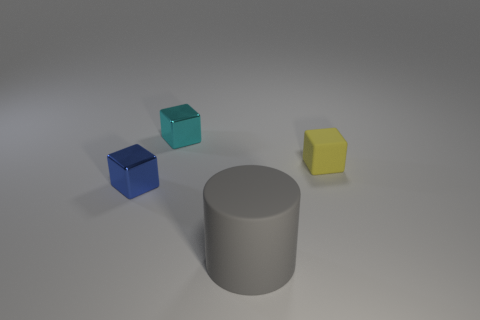Are there more big purple matte cylinders than gray objects?
Make the answer very short. No. Do the tiny blue object and the large gray cylinder that is left of the yellow cube have the same material?
Give a very brief answer. No. How many objects are either matte cubes or tiny metallic things?
Ensure brevity in your answer.  3. Is the size of the matte thing behind the tiny blue thing the same as the rubber thing in front of the tiny yellow thing?
Provide a succinct answer. No. How many cylinders are matte objects or tiny yellow matte things?
Give a very brief answer. 1. Are there any small red things?
Offer a terse response. No. Is there any other thing that has the same shape as the large rubber thing?
Offer a very short reply. No. What number of things are either shiny cubes on the right side of the tiny blue shiny cube or small metal objects?
Keep it short and to the point. 2. There is a small metal block behind the small cube that is right of the big object; what number of small things are in front of it?
Provide a succinct answer. 2. Is there anything else that has the same size as the gray thing?
Offer a terse response. No. 